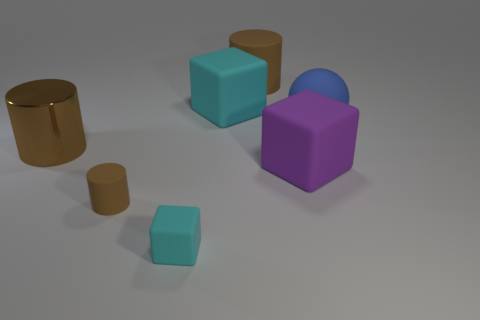Subtract all large cylinders. How many cylinders are left? 1 Add 2 matte objects. How many objects exist? 9 Subtract all cyan cubes. How many cubes are left? 1 Subtract 1 cylinders. How many cylinders are left? 2 Subtract all cubes. How many objects are left? 4 Add 7 brown objects. How many brown objects exist? 10 Subtract 0 blue blocks. How many objects are left? 7 Subtract all yellow balls. Subtract all brown cubes. How many balls are left? 1 Subtract all red blocks. How many red spheres are left? 0 Subtract all rubber cylinders. Subtract all purple matte things. How many objects are left? 4 